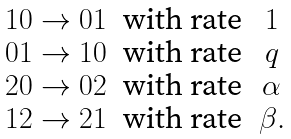<formula> <loc_0><loc_0><loc_500><loc_500>\begin{matrix} & 1 0 \rightarrow 0 1 & \text {with rate} & 1 \\ & 0 1 \rightarrow 1 0 & \text {with rate} & q \\ & 2 0 \rightarrow 0 2 & \text {with rate} & \alpha \\ & 1 2 \rightarrow 2 1 & \text {with rate} & \beta . \end{matrix}</formula> 